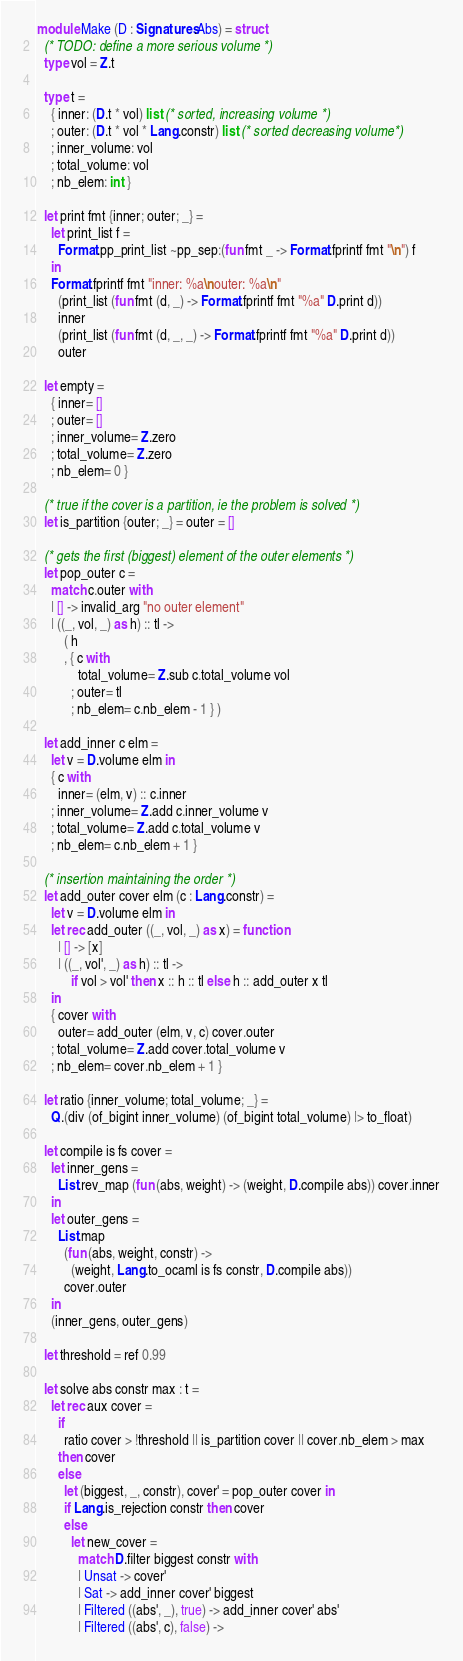<code> <loc_0><loc_0><loc_500><loc_500><_OCaml_>module Make (D : Signatures.Abs) = struct
  (* TODO: define a more serious volume *)
  type vol = Z.t

  type t =
    { inner: (D.t * vol) list (* sorted, increasing volume *)
    ; outer: (D.t * vol * Lang.constr) list (* sorted decreasing volume*)
    ; inner_volume: vol
    ; total_volume: vol
    ; nb_elem: int }

  let print fmt {inner; outer; _} =
    let print_list f =
      Format.pp_print_list ~pp_sep:(fun fmt _ -> Format.fprintf fmt "\n") f
    in
    Format.fprintf fmt "inner: %a\nouter: %a\n"
      (print_list (fun fmt (d, _) -> Format.fprintf fmt "%a" D.print d))
      inner
      (print_list (fun fmt (d, _, _) -> Format.fprintf fmt "%a" D.print d))
      outer

  let empty =
    { inner= []
    ; outer= []
    ; inner_volume= Z.zero
    ; total_volume= Z.zero
    ; nb_elem= 0 }

  (* true if the cover is a partition, ie the problem is solved *)
  let is_partition {outer; _} = outer = []

  (* gets the first (biggest) element of the outer elements *)
  let pop_outer c =
    match c.outer with
    | [] -> invalid_arg "no outer element"
    | ((_, vol, _) as h) :: tl ->
        ( h
        , { c with
            total_volume= Z.sub c.total_volume vol
          ; outer= tl
          ; nb_elem= c.nb_elem - 1 } )

  let add_inner c elm =
    let v = D.volume elm in
    { c with
      inner= (elm, v) :: c.inner
    ; inner_volume= Z.add c.inner_volume v
    ; total_volume= Z.add c.total_volume v
    ; nb_elem= c.nb_elem + 1 }

  (* insertion maintaining the order *)
  let add_outer cover elm (c : Lang.constr) =
    let v = D.volume elm in
    let rec add_outer ((_, vol, _) as x) = function
      | [] -> [x]
      | ((_, vol', _) as h) :: tl ->
          if vol > vol' then x :: h :: tl else h :: add_outer x tl
    in
    { cover with
      outer= add_outer (elm, v, c) cover.outer
    ; total_volume= Z.add cover.total_volume v
    ; nb_elem= cover.nb_elem + 1 }

  let ratio {inner_volume; total_volume; _} =
    Q.(div (of_bigint inner_volume) (of_bigint total_volume) |> to_float)

  let compile is fs cover =
    let inner_gens =
      List.rev_map (fun (abs, weight) -> (weight, D.compile abs)) cover.inner
    in
    let outer_gens =
      List.map
        (fun (abs, weight, constr) ->
          (weight, Lang.to_ocaml is fs constr, D.compile abs))
        cover.outer
    in
    (inner_gens, outer_gens)

  let threshold = ref 0.99

  let solve abs constr max : t =
    let rec aux cover =
      if
        ratio cover > !threshold || is_partition cover || cover.nb_elem > max
      then cover
      else
        let (biggest, _, constr), cover' = pop_outer cover in
        if Lang.is_rejection constr then cover
        else
          let new_cover =
            match D.filter biggest constr with
            | Unsat -> cover'
            | Sat -> add_inner cover' biggest
            | Filtered ((abs', _), true) -> add_inner cover' abs'
            | Filtered ((abs', c), false) -></code> 